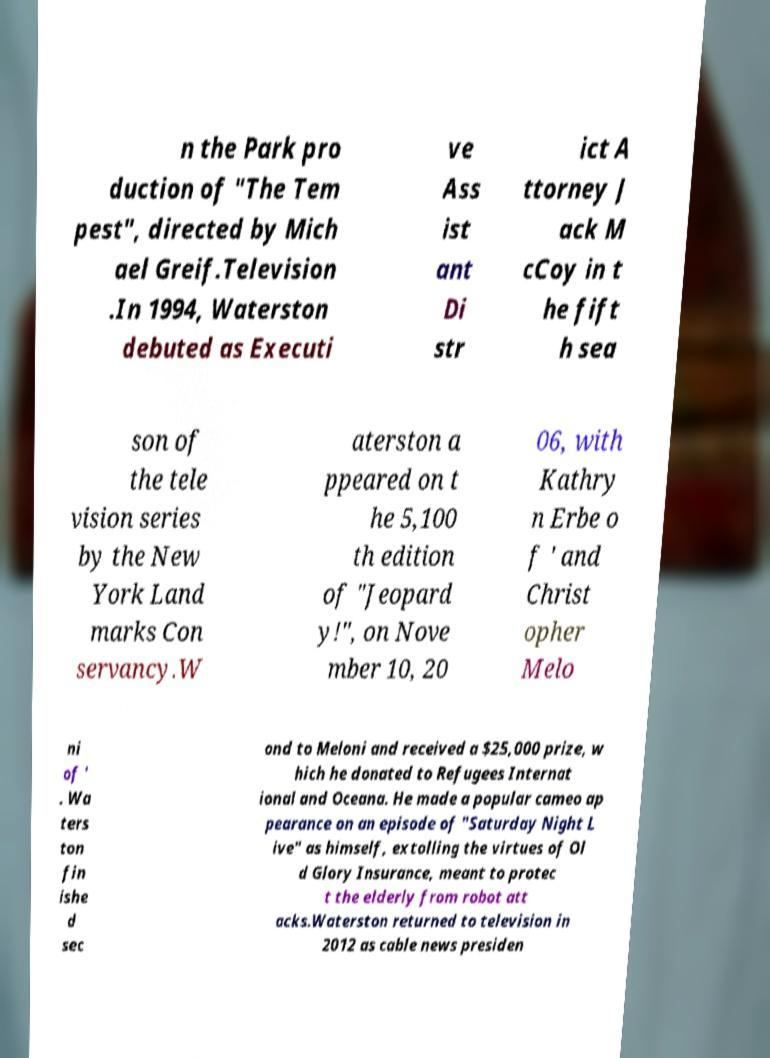What messages or text are displayed in this image? I need them in a readable, typed format. n the Park pro duction of "The Tem pest", directed by Mich ael Greif.Television .In 1994, Waterston debuted as Executi ve Ass ist ant Di str ict A ttorney J ack M cCoy in t he fift h sea son of the tele vision series by the New York Land marks Con servancy.W aterston a ppeared on t he 5,100 th edition of "Jeopard y!", on Nove mber 10, 20 06, with Kathry n Erbe o f ' and Christ opher Melo ni of ' . Wa ters ton fin ishe d sec ond to Meloni and received a $25,000 prize, w hich he donated to Refugees Internat ional and Oceana. He made a popular cameo ap pearance on an episode of "Saturday Night L ive" as himself, extolling the virtues of Ol d Glory Insurance, meant to protec t the elderly from robot att acks.Waterston returned to television in 2012 as cable news presiden 